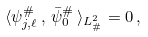Convert formula to latex. <formula><loc_0><loc_0><loc_500><loc_500>\langle \psi _ { j , \ell } ^ { \# } \, , \, \bar { \psi } _ { 0 } ^ { \# } \, \rangle _ { L ^ { 2 } _ { \# } } = 0 \, ,</formula> 